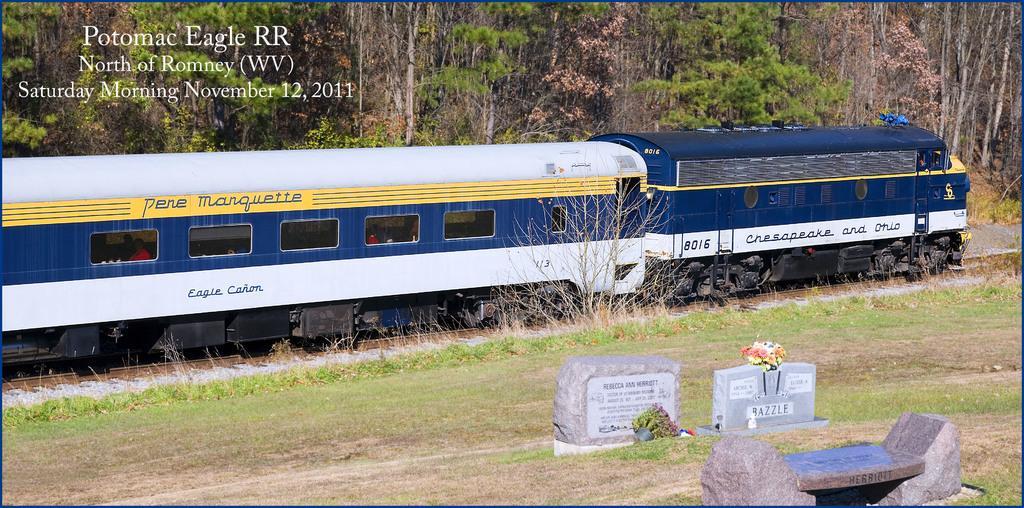Can you describe this image briefly? In the image a train is moving on a track. There are few grave stones on a side of the track. There are some trees behind the train. 